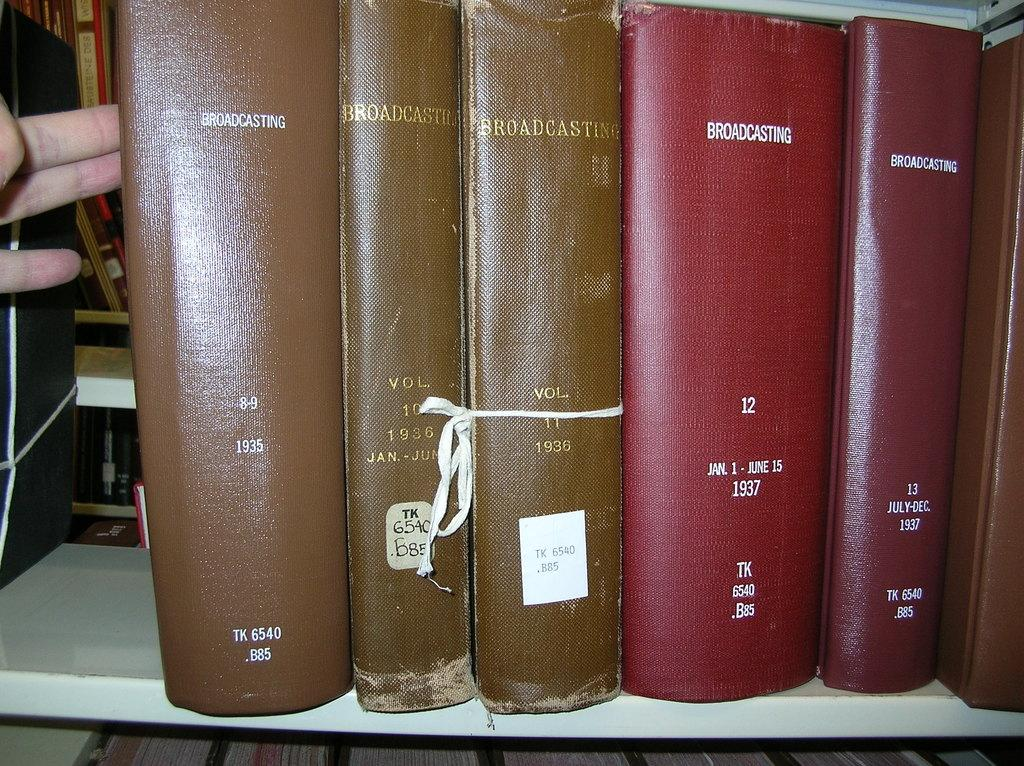<image>
Create a compact narrative representing the image presented. At least five books titled Broadcasting placed on a white shelf. 